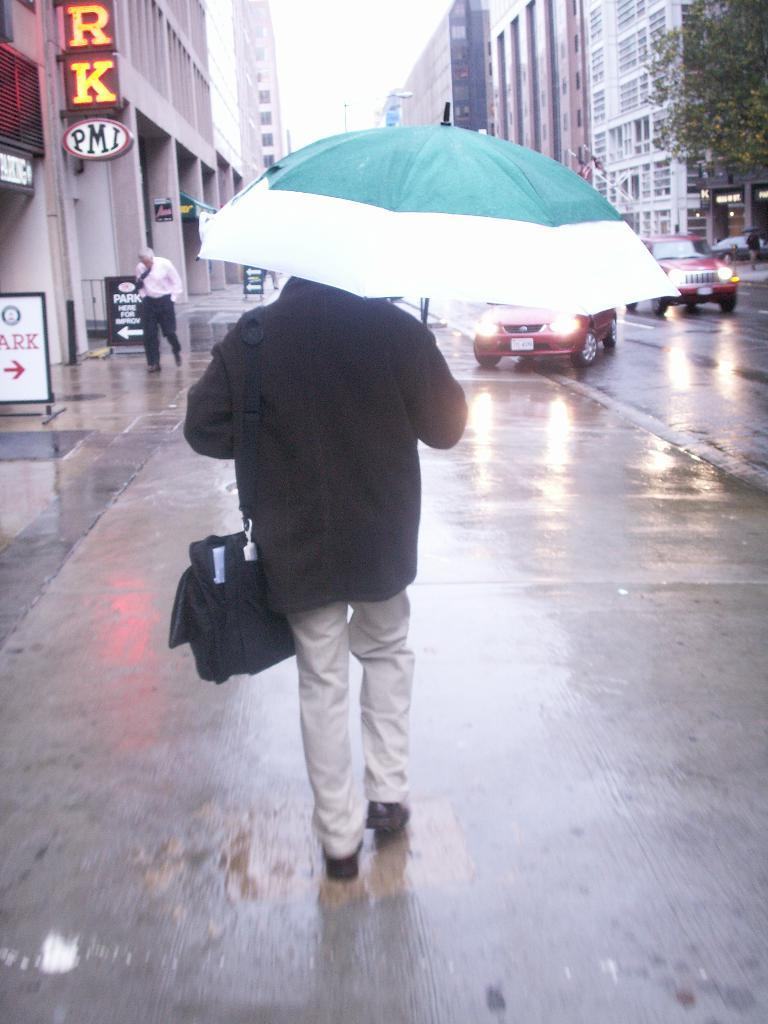What is the person in the image holding along with an umbrella? The person is also holding a wire bag. What can be seen in the background of the image? There are buildings, boards, people, a tree, and the sky visible in the background of the image. What is present on the road in the image? Vehicles are present on the road in the image. What type of oatmeal is being served on the boards in the image? There is no oatmeal present in the image, and the boards are not serving any food. What need is being fulfilled by the person holding the umbrella in the image? The image does not provide information about the person's needs or intentions, so we cannot determine what need is being fulfilled. 